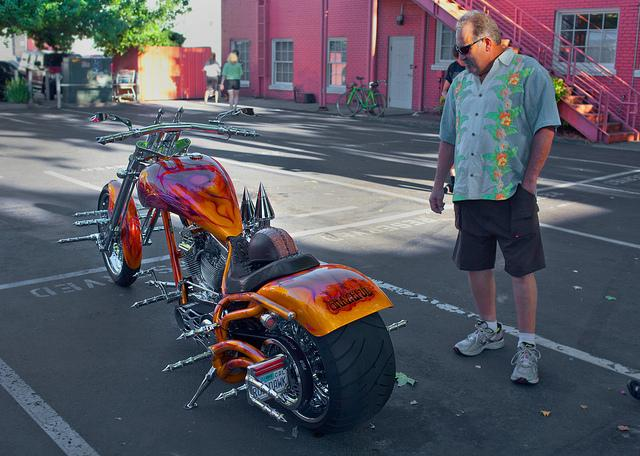How was this type of bike made? Please explain your reasoning. custom. The bike is custom. 